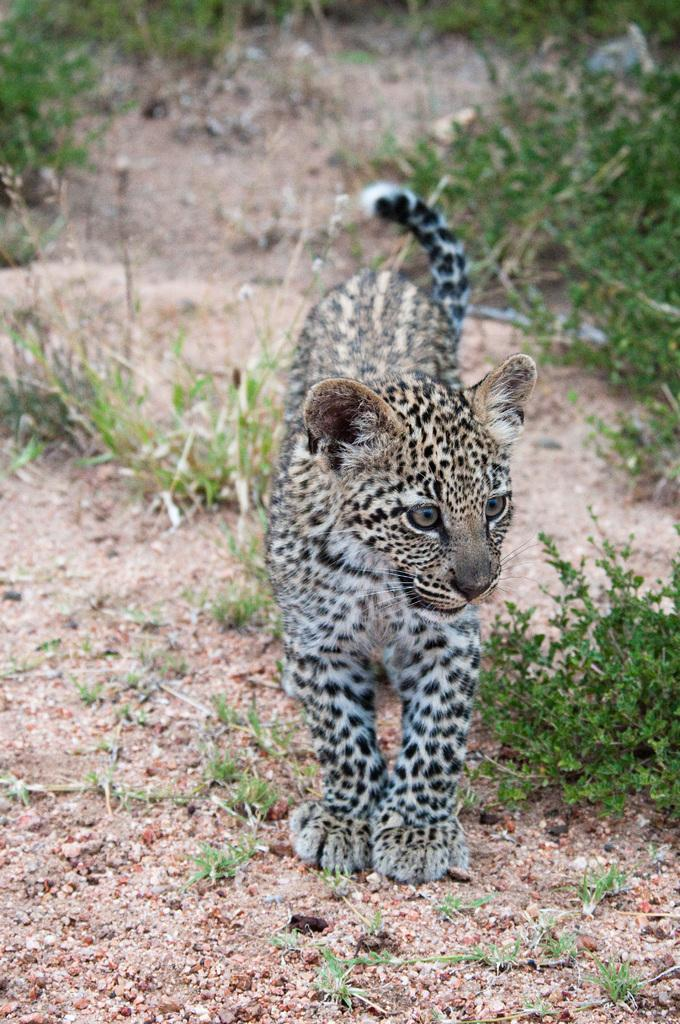What animal is the main subject of the image? There is a cheetah cub in the image. What is the cheetah cub's position in the image? The cheetah cub is standing on the land. What can be seen in the background of the image? There are plants visible in the background of the image. What type of jam is the cheetah cub eating in the image? There is no jam present in the image; the cheetah cub is standing on the land. Is there a book visible in the image? No, there is no book present in the image. 